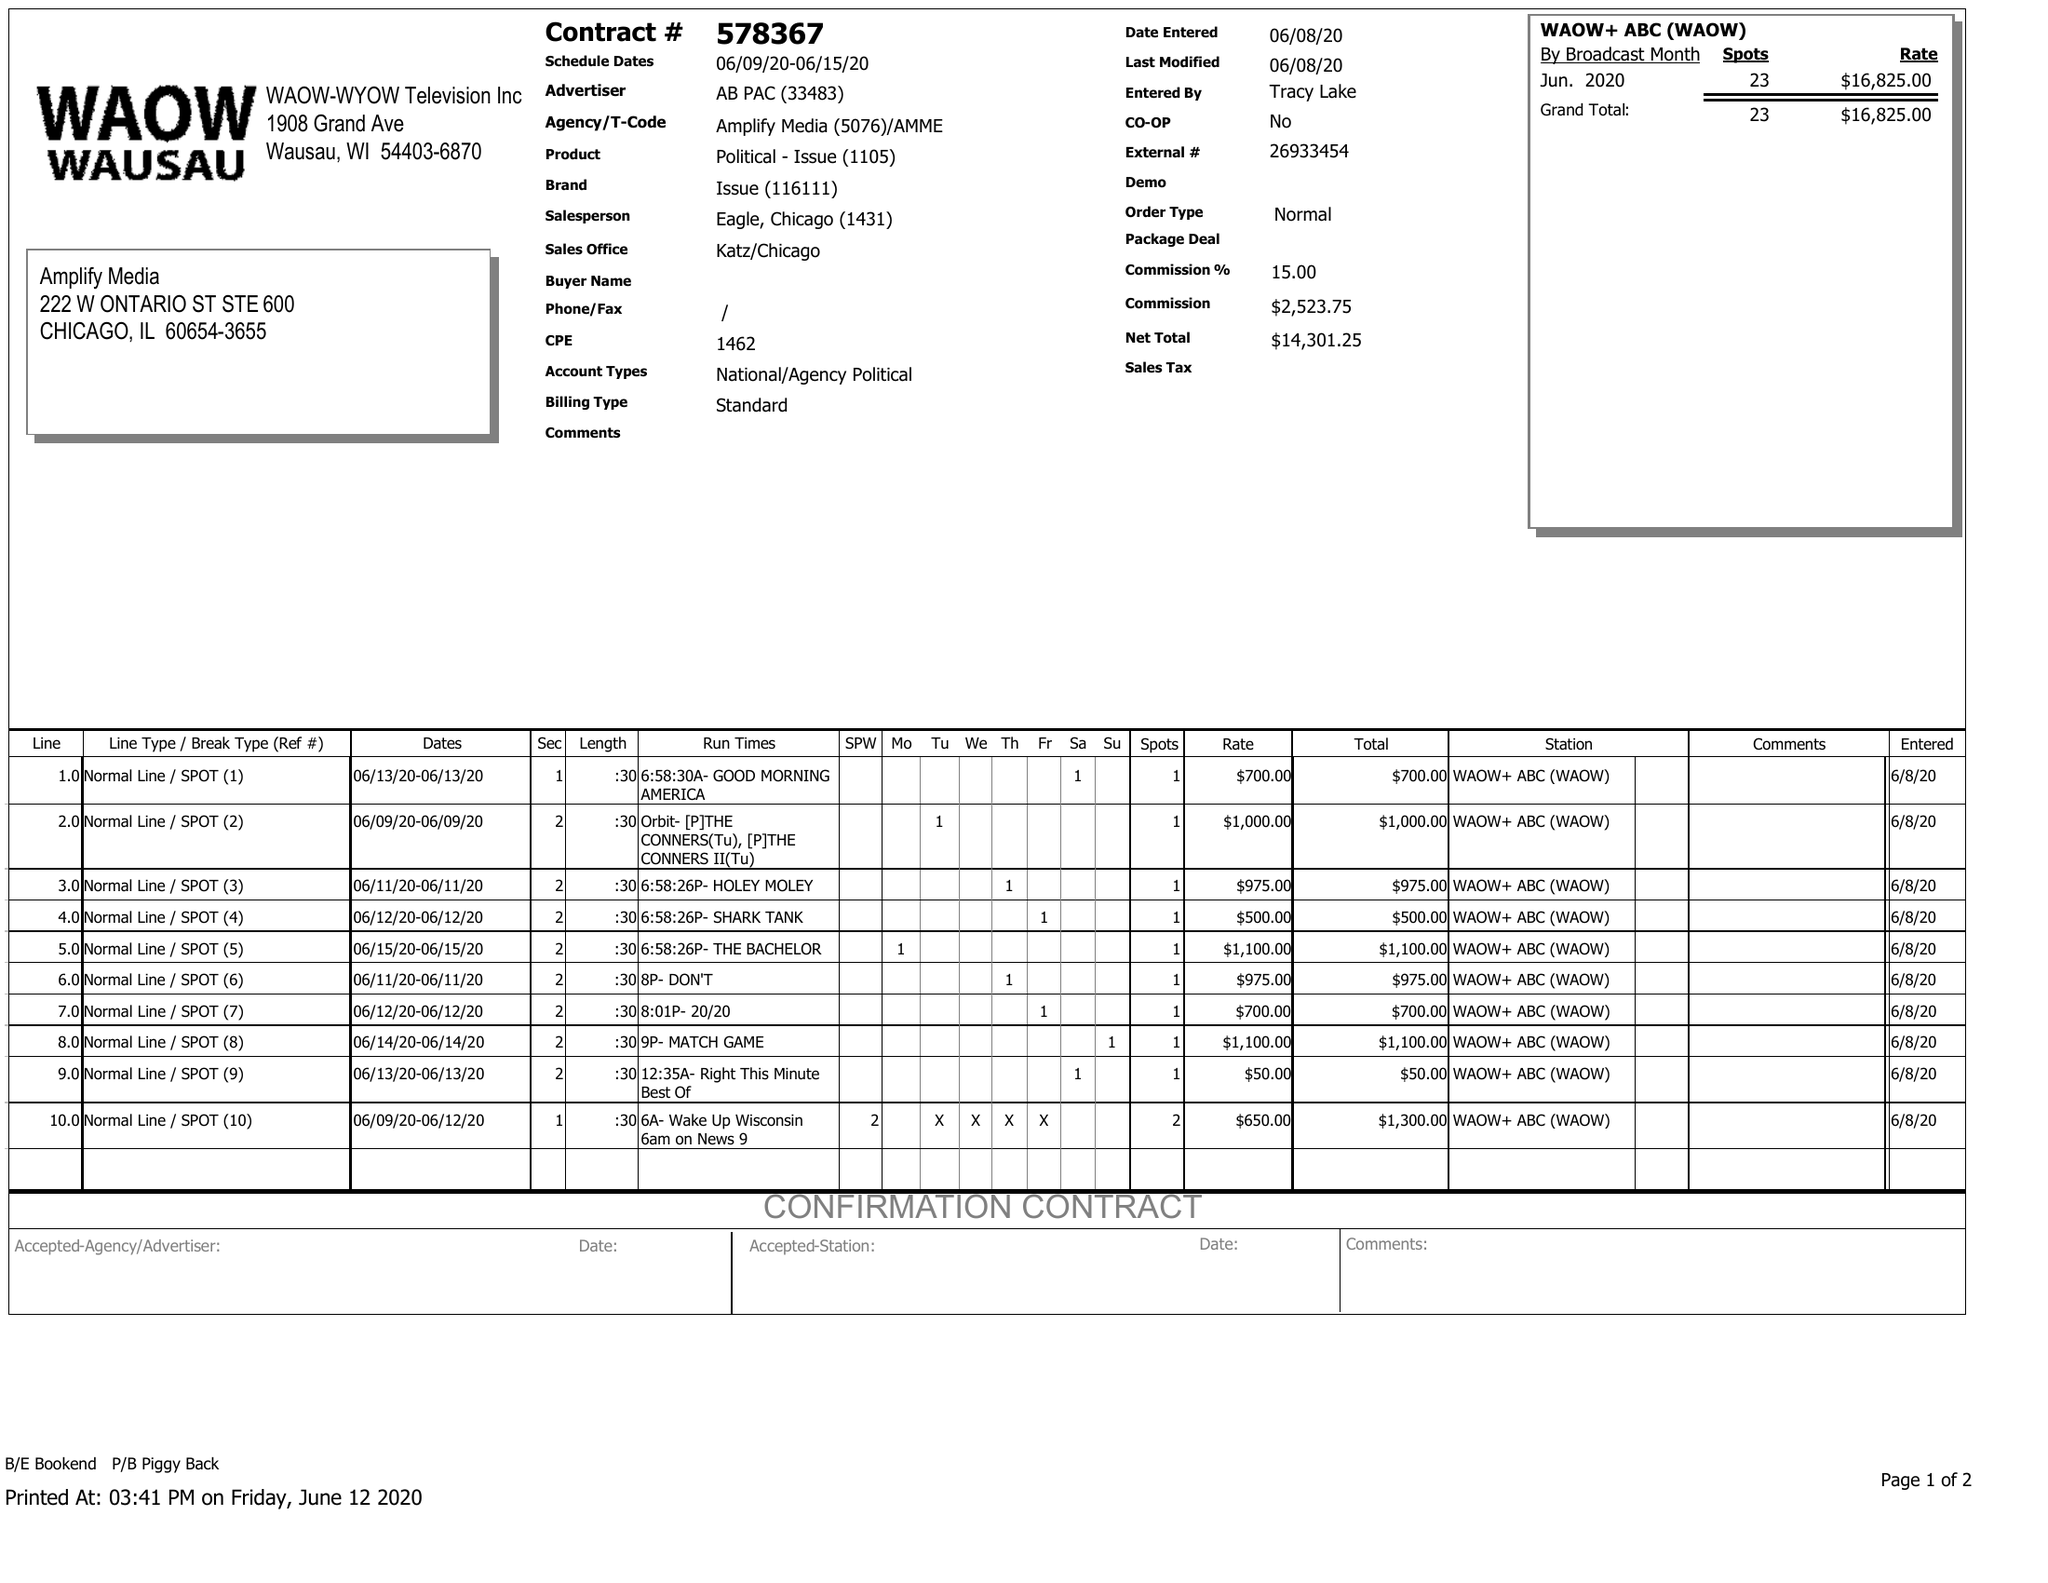What is the value for the contract_num?
Answer the question using a single word or phrase. 578367 